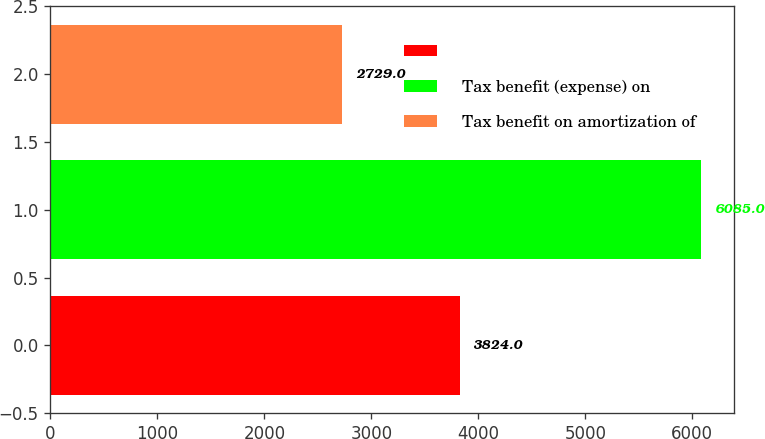<chart> <loc_0><loc_0><loc_500><loc_500><bar_chart><ecel><fcel>Tax benefit (expense) on<fcel>Tax benefit on amortization of<nl><fcel>3824<fcel>6085<fcel>2729<nl></chart> 